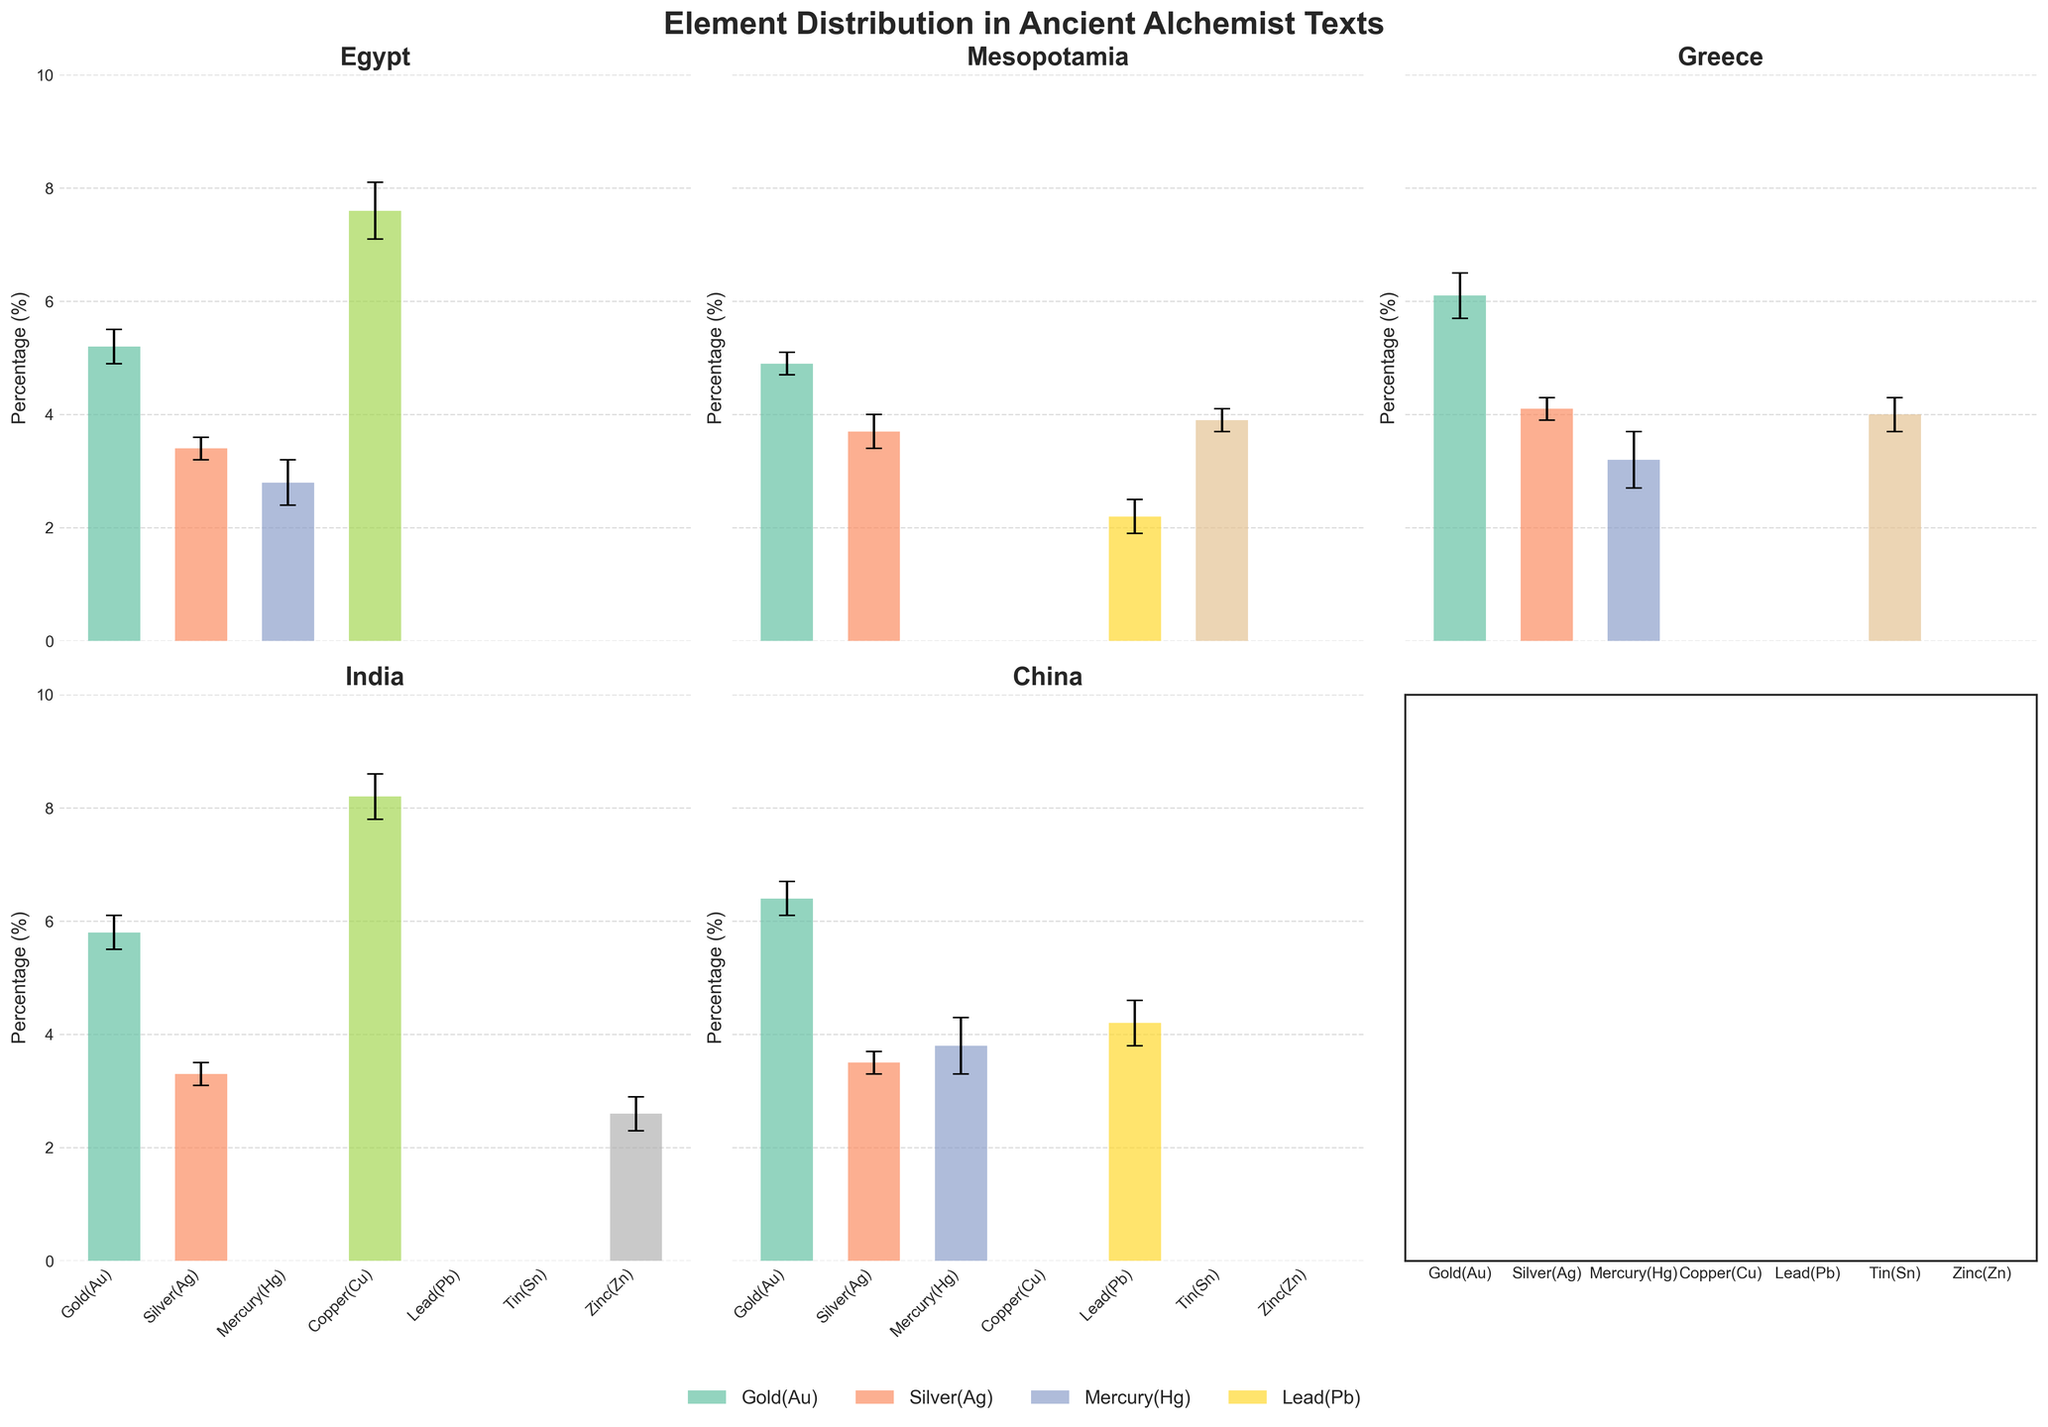How is the title of the figure related to the data shown? The title 'Element Distribution in Ancient Alchemist Texts' suggests that the figure visualizes the distribution of elements mentioned in historical alchemist texts across regions. The data is presented as percentages of each element with error bars to indicate variability.
Answer: It summarizes the data visualization Which region has the highest percentage of Copper (Cu)? To determine this, one needs to compare the bars representing Copper (Cu) across different subplots. From the figure, India has the highest Copper percentage (8.2%).
Answer: India What is the difference in the percentage of Gold (Au) between China and Mesopotamia? First, locate and compare the bars for Gold (Au) in the China and Mesopotamia subplots. China has 6.4%, and Mesopotamia has 4.9%. The difference is 6.4% - 4.9% = 1.5%.
Answer: 1.5% Is the percentage of Zinc (Zn) in India higher or lower than the percentage of Mercury (Hg) in Egypt? Find the bar for Zinc (Zn) in the India subplot (2.6%) and compare it to the bar for Mercury (Hg) in the Egypt subplot (2.8%). Zinc in India is lower.
Answer: Lower Which element shows the highest variability in Greece? Analyze the error bars for elements in the Greece subplot. Mercury (Hg) has the largest error bar, indicating the highest variability.
Answer: Mercury (Hg) What is the sum of the percentages of Silver (Ag) in all regions? Add up the percentages of Silver (Ag) for Egypt (3.4%), Mesopotamia (3.7%), Greece (4.1%), India (3.3%), and China (3.5%). The sum is 3.4 + 3.7 + 4.1 + 3.3 + 3.5 = 18%.
Answer: 18% Which region has the most uniform distribution of element percentages (smallest range between highest and lowest percentages)? Calculate the range of percentages for each region and identify the smallest. Egypt: 7.6-2.8=4.8; Mesopotamia: 4.9-2.2=2.7; Greece: 6.1-3.2=2.9; India: 8.2-2.6=5.6; China: 6.4-3.5=2.9. Mesopotamia has the smallest range (2.7).
Answer: Mesopotamia What element is missing from the texts of Greece but present in texts of India? Compare the elements listed in the subplots for Greece and India. Zinc (Zn) is present in India but not in Greece.
Answer: Zinc (Zn) Are the percentages of Lead (Pb) higher in Mesopotamia or China? Compare the bars for Lead (Pb) in the Mesopotamia subplot (2.2%) and the China subplot (4.2%). China has a higher percentage of Lead.
Answer: China Which region has the highest overall average percentage of elements? Calculate the average percentage of all elements for each region: 
Egypt: (5.2+3.4+2.8+7.6)/4 = 4.75%; 
Mesopotamia: (4.9+3.7+2.2+3.9)/4 = 3.675%; 
Greece: (6.1+4.1+3.2+4.0)/4 = 4.35%; 
India: (5.8+3.3+8.2+2.6)/4 = 4.975%; 
China: (6.4+3.5+3.8+4.2)/4 = 4.475%. 
India has the highest average percentage (4.975%).
Answer: India 